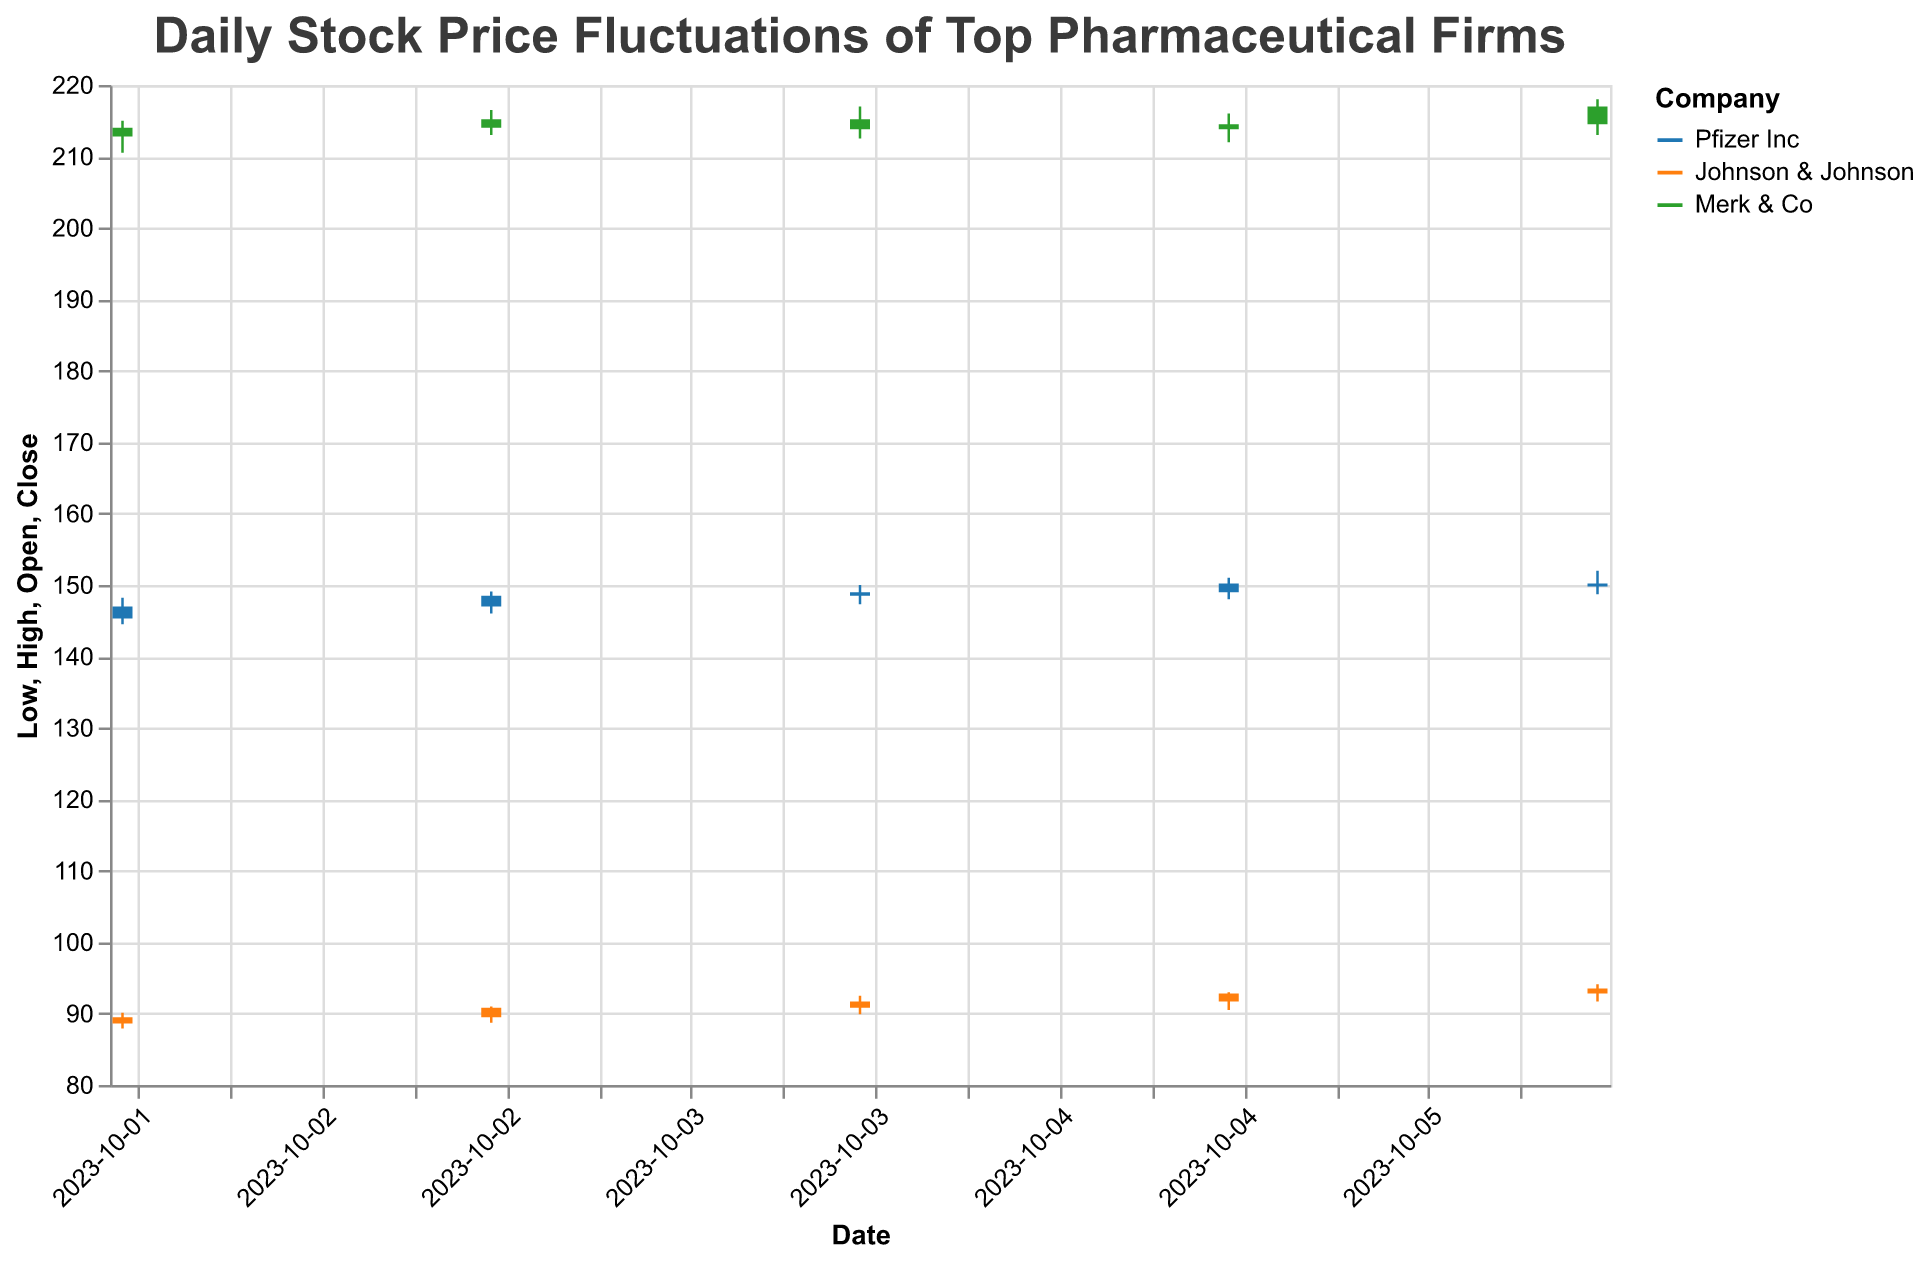What is the title of the figure? The title is usually located at the top of the chart and should succinctly describe what the figure is about. In this case, it is "Daily Stock Price Fluctuations of Top Pharmaceutical Firms."
Answer: Daily Stock Price Fluctuations of Top Pharmaceutical Firms How many companies' stock price data are shown in the figure? There are three distinct colors in the figure's legend, which correspond to the companies "Pfizer Inc," "Johnson & Johnson," and "Merk & Co." Therefore, the figure shows data for three companies.
Answer: 3 On October 4th, which company had the highest closing price? By examining the candlestick data for October 4th, we see the closing prices for Pfizer Inc (149.00), Johnson & Johnson (91.70), and Merk & Co (213.80). "Merk & Co" has the highest closing price.
Answer: Merk & Co Which company had the greatest difference between its highest and lowest prices on October 6th? To find the greatest difference, we calculate (Highest - Lowest) for each company on October 6th: 
Pfizer Inc: (152.00 - 148.70) = 3.30
Johnson & Johnson: (94.10 - 91.70) = 2.40
Merk & Co: (218.00 - 213.00) = 5.00
"Merk & Co" had the greatest difference (5.00).
Answer: Merk & Co Which company had an increasing stock price for four consecutive days? We need to check each day’s closing prices for consistency in increasing order:
Pfizer Inc: 147.00 → 148.50 → 149.00 → 150.20, which is increasing.
Johnson & Johnson and Merk & Co do not meet this criterion. Therefore, "Pfizer Inc" is the company with increasing stock prices.
Answer: Pfizer Inc What was the highest volume of trades for Pfizer Inc over these five days? We refer to the volume column for Pfizer Inc entries and find the maximum value: 1204000, 1100000, 1150000, 1230000, 1185000. The highest volume is 1230000.
Answer: 1230000 Compare the opening price of Johnson & Johnson on October 3rd and October 4th. Did it increase or decrease? The opening prices of Johnson & Johnson are 89.50 on October 3rd and 90.80 on October 4th. By comparing, we see that it increased from 89.50 to 90.80.
Answer: Increased What was the largest single-day gain in closing price for Merk & Co within the time frame? Calculate the difference in closing prices between two consecutive days for Merk & Co:
 October 2nd to 3rd: 214.00 - 215.20 = 1.20
 October 3rd to 4th: 215.20 - 213.80 = -1.40 (not a gain)
 October 4th to 5th: 213.80 - 214.50 = 0.70
 October 5th to 6th: 214.50 - 217.00 = 2.50
The largest single-day gain is from October 5th to 6th, which is 2.50.
Answer: 2.50 